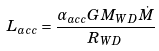<formula> <loc_0><loc_0><loc_500><loc_500>L _ { a c c } = \frac { \alpha _ { a c c } G M _ { W D } \dot { M } } { R _ { W D } }</formula> 